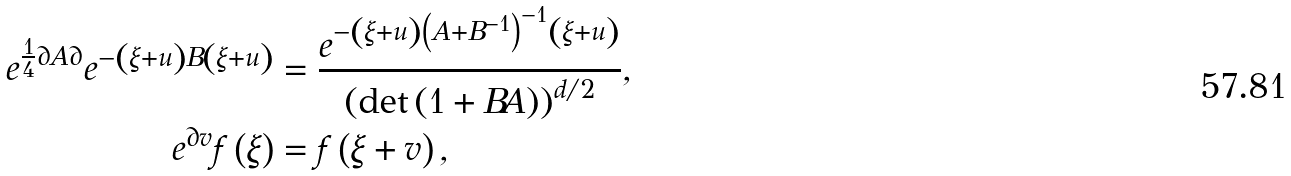<formula> <loc_0><loc_0><loc_500><loc_500>e ^ { \frac { 1 } { 4 } \partial A \partial } e ^ { - \left ( \xi + u \right ) B \left ( \xi + u \right ) } & = \frac { e ^ { - \left ( \xi + u \right ) \left ( A + B ^ { - 1 } \right ) ^ { - 1 } \left ( \xi + u \right ) } } { \left ( \det \left ( 1 + B A \right ) \right ) ^ { d / 2 } } , \\ e ^ { \partial v } f \left ( \xi \right ) & = f \left ( \xi + v \right ) ,</formula> 